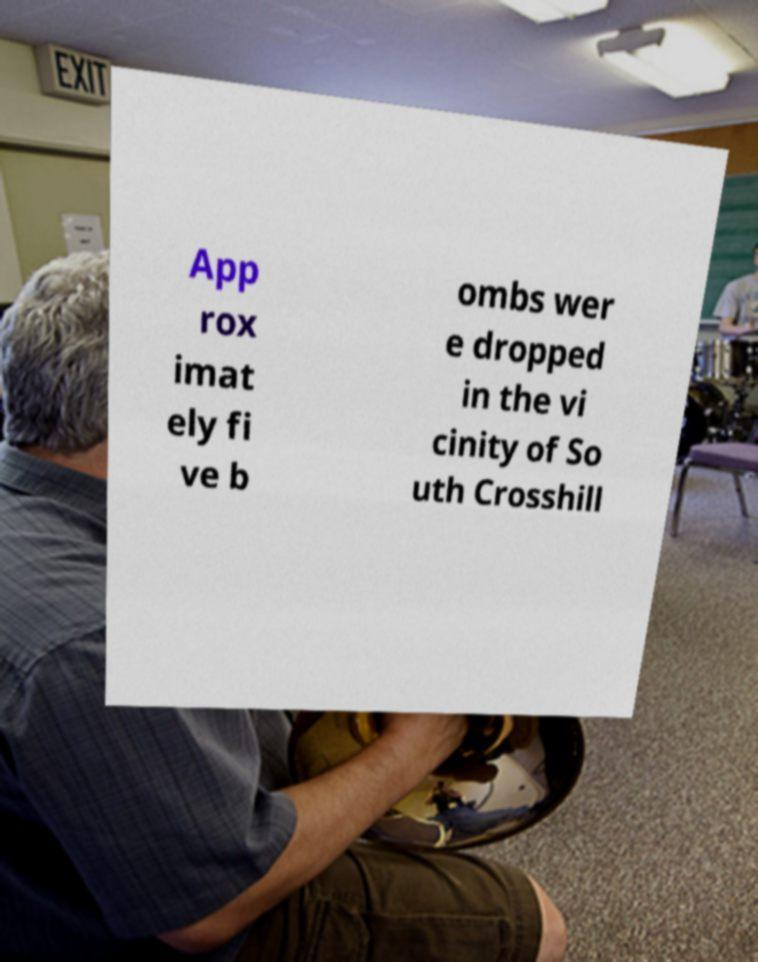Could you extract and type out the text from this image? App rox imat ely fi ve b ombs wer e dropped in the vi cinity of So uth Crosshill 